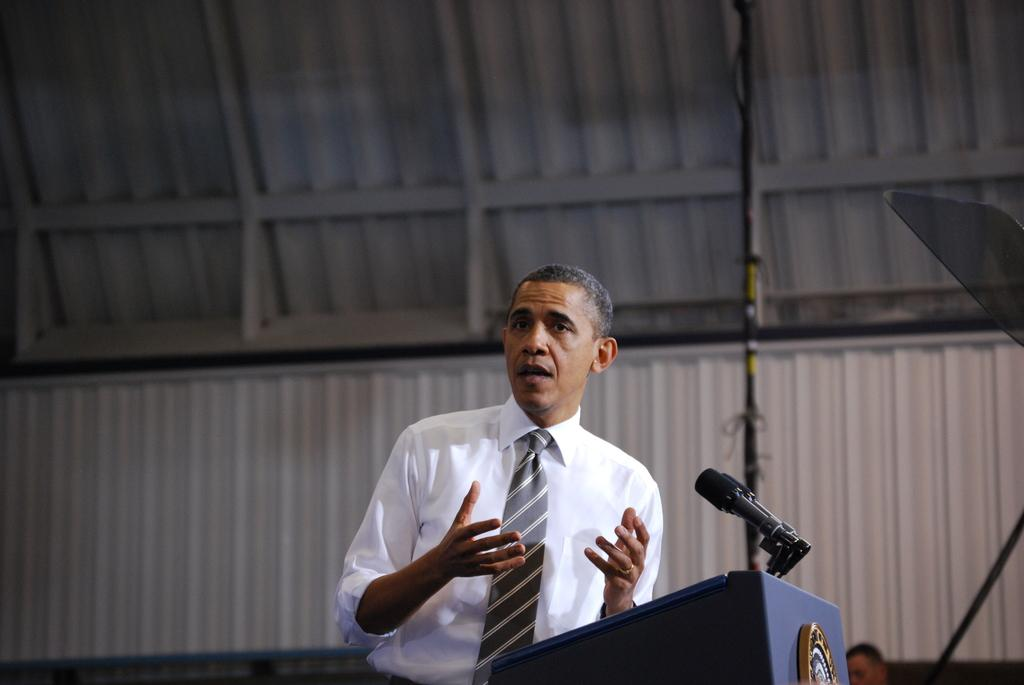What is the main subject of the image? There is a man standing in the image. Can you describe the man's attire? The man is wearing clothes. What accessory is the man wearing on his finger? The man is wearing a finger ring. What might the man be doing in the image? It appears that the man is talking. What object is present in the image that is typically used for speeches or presentations? There is a podium in the image. What devices are present in the image that are used for amplifying sound? There are microphones in the image. How would you describe the background of the image? The background of the image is slightly blurred. What type of treatment is the pig receiving in the image? There is no pig present in the image, and therefore no treatment can be observed. 